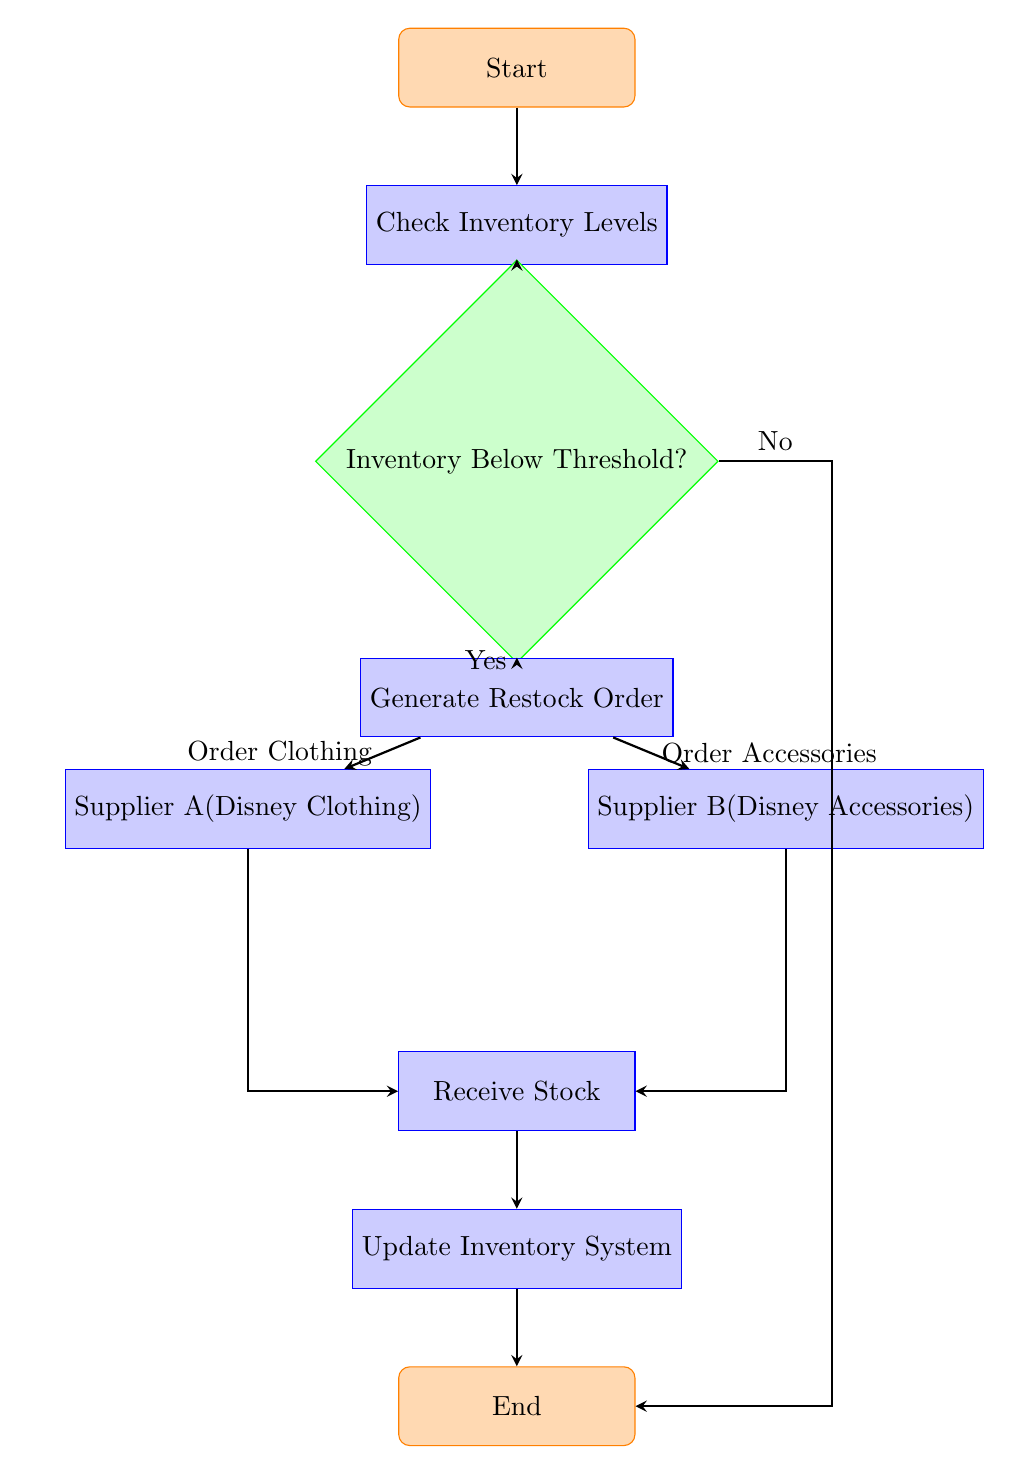What is the first step in the workflow? The first step in the workflow, as indicated by the starting node, is to "Start". This is the initial action that begins the process.
Answer: Start How many decision nodes are in the diagram? The diagram contains one decision node, which asks if the "Inventory Below Threshold?". This node leads to two different paths based on the answer.
Answer: One What happens if the inventory is not below the threshold? If the inventory is not below the threshold, as indicated by the "No" decision from the decision node, the flow moves directly to the "End" node without generating a restock order or placing any orders with suppliers.
Answer: End What is the process after receiving stock? After receiving stock, the next step in the diagram is to "Update Inventory System". This shows that the system needs to be updated with the new inventory data following the stock receipt.
Answer: Update Inventory System How many suppliers are involved in the restocking process? The restocking process involves two suppliers: "Supplier A (Disney Clothing)" and "Supplier B (Disney Accessories)". Both suppliers are identified in the steps following the generation of the restock order.
Answer: Two What action is taken after generating the restock order? After generating the restock order, there are two actions that can be taken depending on the type of stock needed. The flow can either go to "Supplier A" for clothing or "Supplier B" for accessories. Both actions are shown as separate processes stemming from the generated order.
Answer: Supplier A and Supplier B What action leads directly to the update of the inventory system? The direct action that leads to updating the inventory system is the "Receive Stock" process. This indicates that stock must be received before the inventory can be updated in the system.
Answer: Receive Stock What step follows the decision node? After the decision node, the next step is the "Generate Restock Order" if the inventory is below the threshold. This node is crucial as it determines the restocking process.
Answer: Generate Restock Order 